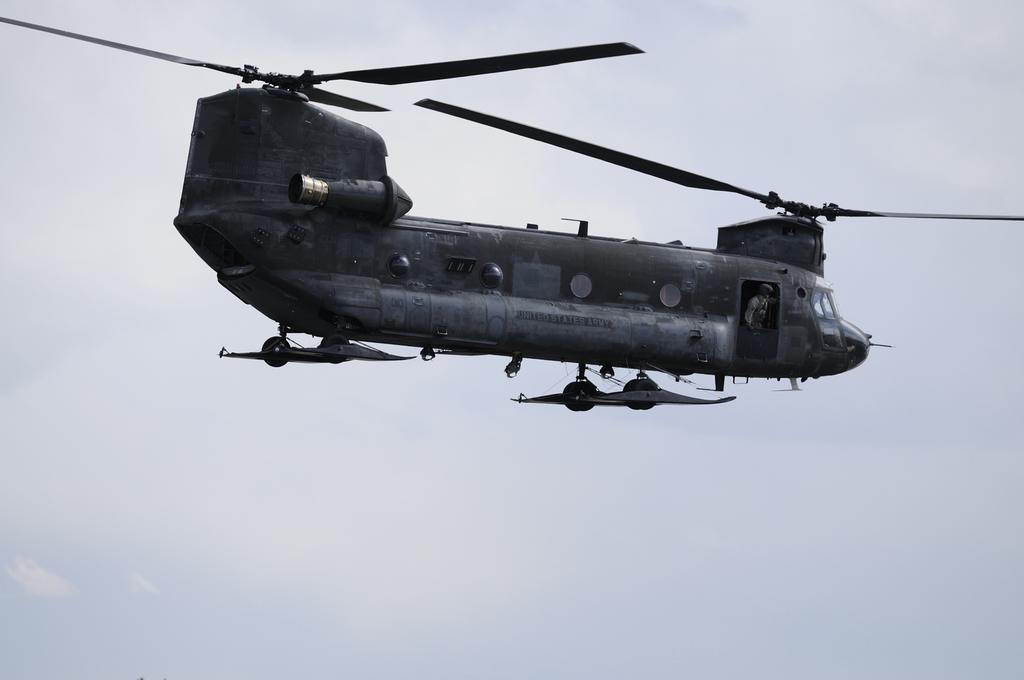Describe this image in one or two sentences. In this picture I can see a helicopter in front and in the background I see the sky. 